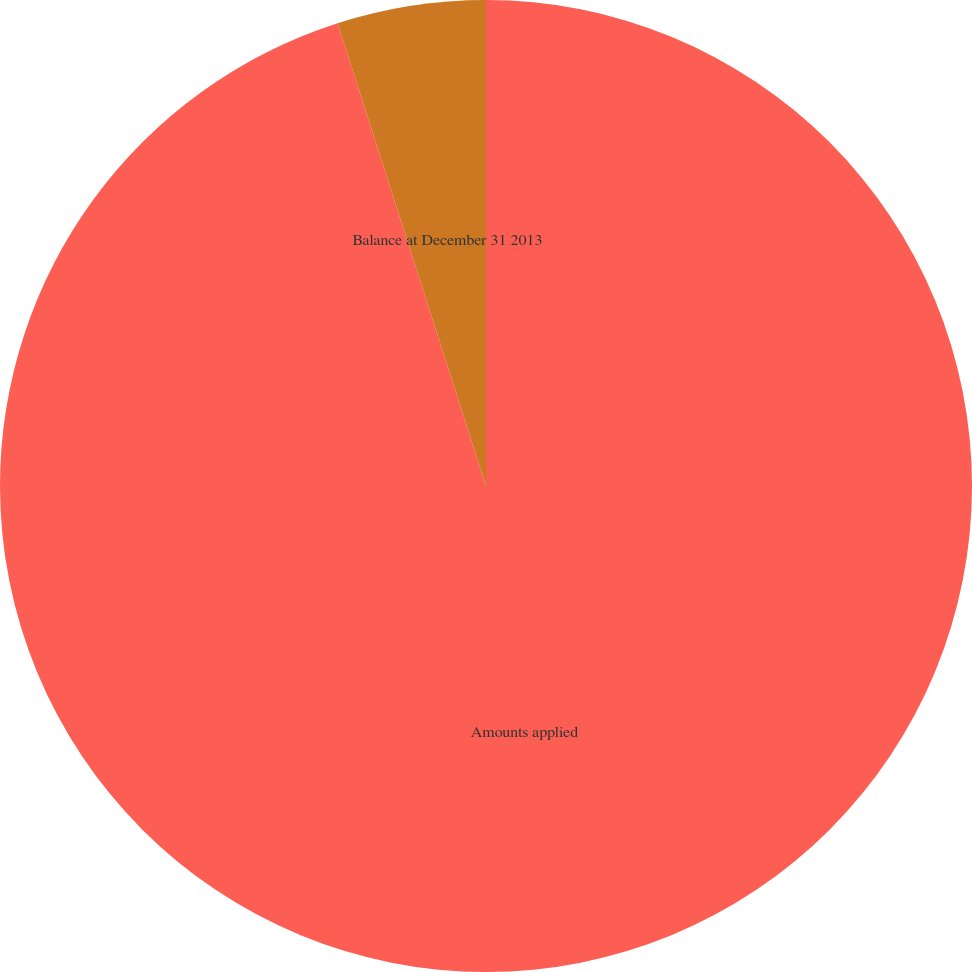Convert chart to OTSL. <chart><loc_0><loc_0><loc_500><loc_500><pie_chart><fcel>Amounts applied<fcel>Balance at December 31 2013<nl><fcel>95.06%<fcel>4.94%<nl></chart> 